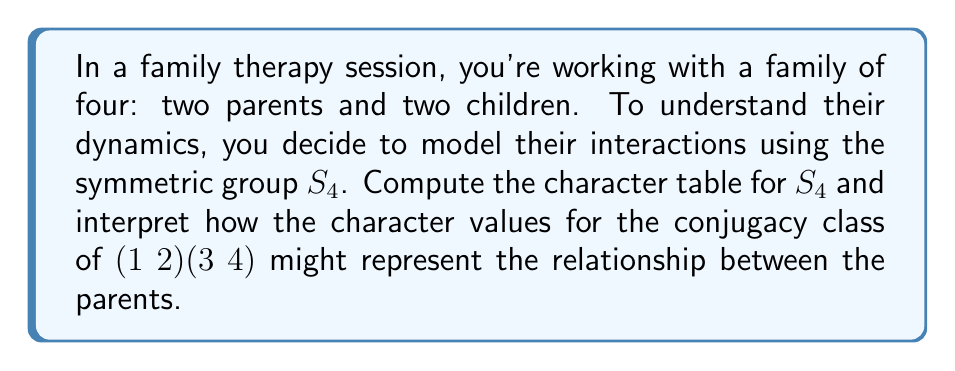Solve this math problem. To compute the character table for $S_4$ and interpret its relevance to family dynamics, we'll follow these steps:

1) First, identify the conjugacy classes of $S_4$:
   - $[1]$: identity
   - $[2]$: (1 2), (1 3), (1 4), (2 3), (2 4), (3 4)
   - $[3]$: (1 2 3), (1 3 2), (1 2 4), (1 4 2), (1 3 4), (1 4 3), (2 3 4), (2 4 3)
   - $[2,2]$: (1 2)(3 4), (1 3)(2 4), (1 4)(2 3)
   - $[4]$: (1 2 3 4), (1 3 4 2), (1 4 2 3), (1 2 4 3), (1 4 3 2), (1 3 2 4)

2) Determine the irreducible representations:
   - Trivial representation: $\chi_1$
   - Sign representation: $\chi_2$
   - Standard representation: $\chi_3$
   - $\chi_4$ (obtained from $\chi_3 \otimes \chi_2$)
   - $\chi_5$ (5-dimensional representation)

3) Compute the character values:

$$
\begin{array}{c|ccccc}
   & [1] & [2] & [3] & [2,2] & [4] \\
\hline
\chi_1 & 1 & 1 & 1 & 1 & 1 \\
\chi_2 & 1 & -1 & 1 & 1 & -1 \\
\chi_3 & 3 & 1 & 0 & -1 & -1 \\
\chi_4 & 3 & -1 & 0 & -1 & 1 \\
\chi_5 & 2 & 0 & -1 & 2 & 0
\end{array}
$$

4) Interpret the character values for (1 2)(3 4):
   The conjugacy class $[2,2]$ represents pairwise interactions, which could model the relationship between the parents. The character values for this class are:
   - $\chi_1(2,2) = 1$: No change in the family system.
   - $\chi_2(2,2) = 1$: Positive interaction between parents.
   - $\chi_3(2,2) = -1$ and $\chi_4(2,2) = -1$: Potential conflict or negative impact on the family structure.
   - $\chi_5(2,2) = 2$: Strong influence on the family dynamics, possibly indicating a dominant parental relationship.

These values suggest that the parental relationship has a significant impact on the family system, with both positive and potentially challenging aspects.
Answer: Character table of $S_4$ with $[2,2]$ class representing parental dynamics: $\{1, 1, -1, -1, 2\}$. 